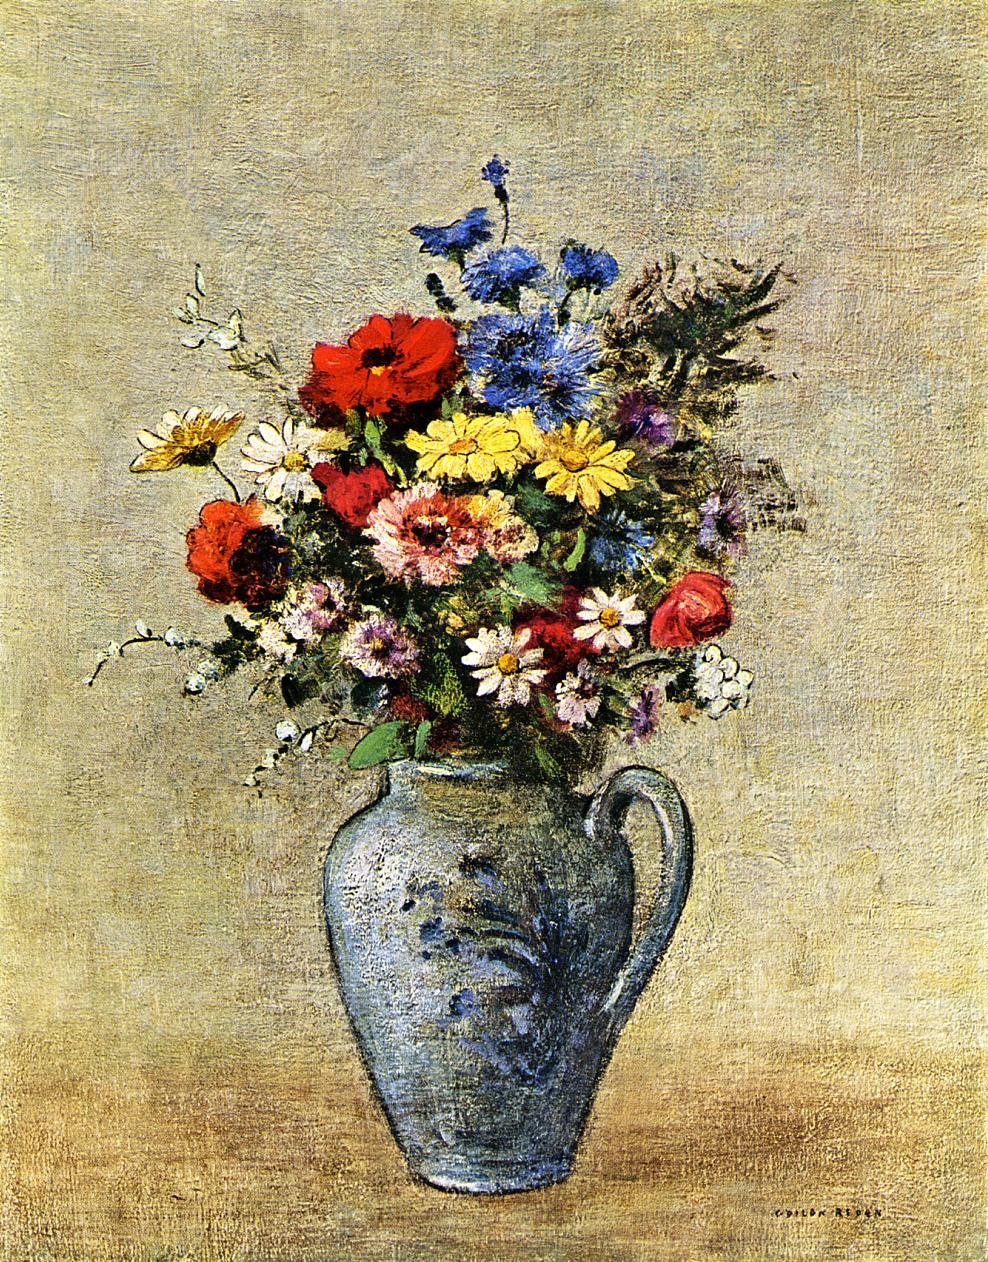Describe the following image. The image depicts a vibrant still life painting, rendered in an impressionist style. At the heart of the artwork lies a bouquet of assorted flowers, featuring blooms in red, yellow, pink, white, blue, and purple, artistically arranged in an elegantly curved blue-grey vase. The vase itself alludes to classical designs, evoking a timeless aesthetic. The backdrop is a subtly textured beige, enhancing the vivid colors and dynamic brushwork typical of the impressionist movement. This style highlights the interplay of light and color, aiming to capture fleeting moments from everyday life and provoking an emotional response from the viewer. Additionally, such a piece often invites interpretations regarding the artist’s emotional state and the socio-cultural milieu during which it was created. 